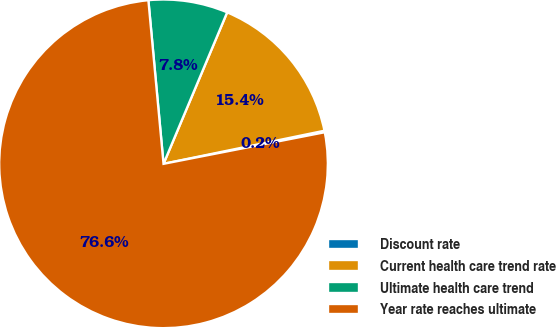Convert chart to OTSL. <chart><loc_0><loc_0><loc_500><loc_500><pie_chart><fcel>Discount rate<fcel>Current health care trend rate<fcel>Ultimate health care trend<fcel>Year rate reaches ultimate<nl><fcel>0.15%<fcel>15.44%<fcel>7.8%<fcel>76.61%<nl></chart> 